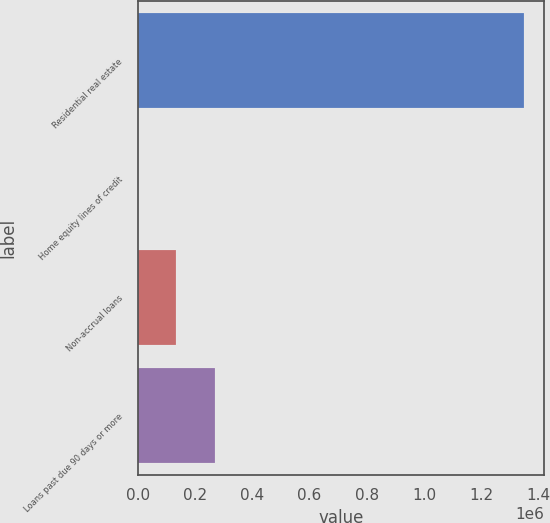Convert chart. <chart><loc_0><loc_0><loc_500><loc_500><bar_chart><fcel>Residential real estate<fcel>Home equity lines of credit<fcel>Non-accrual loans<fcel>Loans past due 90 days or more<nl><fcel>1.35061e+06<fcel>280<fcel>135313<fcel>270346<nl></chart> 